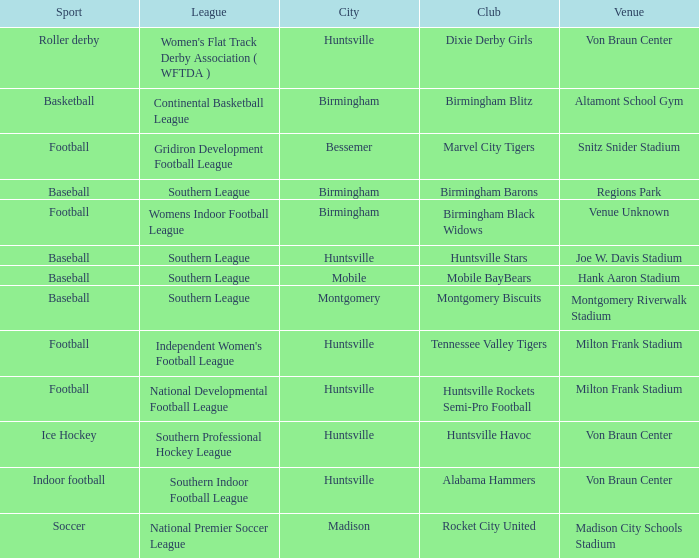Which venue hosted the Dixie Derby Girls? Von Braun Center. 